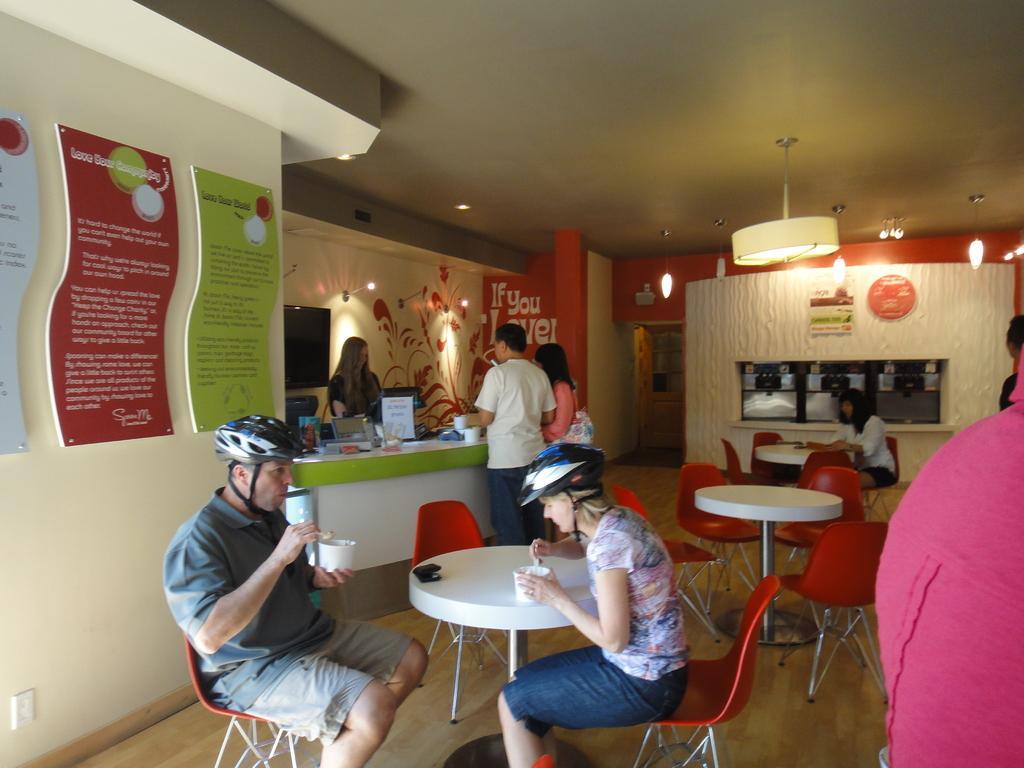Describe this image in one or two sentences. This is the picture of a Cafeteria where we have some chairs and tables and a cabin in which a lady is standing and there are some people sitting on the chairs. 